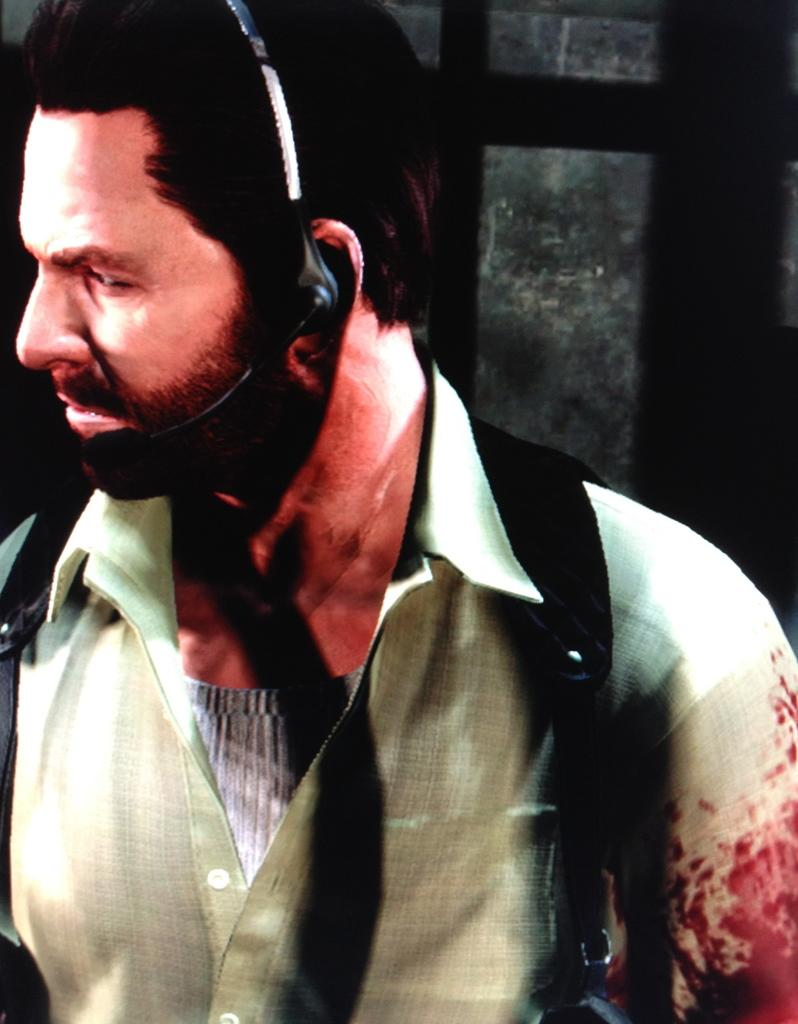Who is the main subject in the image? There is a man in the center of the image. What is the man wearing on his head? The man is wearing a headset. What is the man carrying in the image? The man is carrying a bag. What can be seen in the background of the image? There is a window visible in the background of the image. What type of pump can be seen in the man's hand in the image? There is no pump present in the man's hand or in the image. How many mittens is the man wearing in the image? The man is not wearing any mittens in the image. 